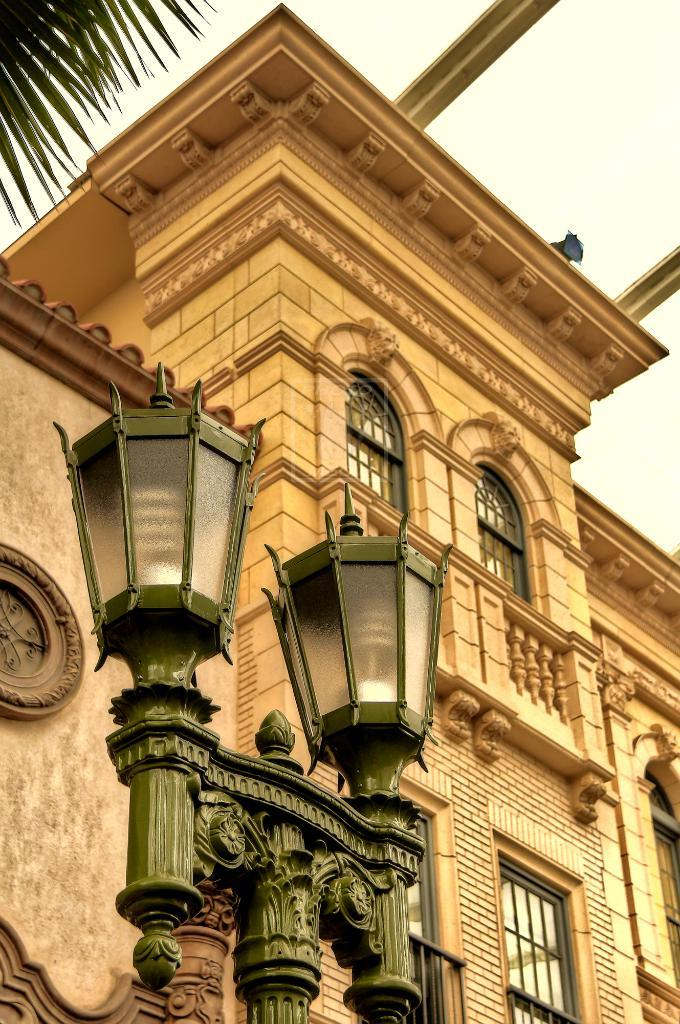What type of structure is present in the image? There is a building in the image. What feature of the building is mentioned in the facts? The building has windows. What can be observed about the windows in the image? The windows have lights. What other object is present in the image? There is a pole in the image. What type of natural element is present in the image? There is a tree in the image. What can be seen in the background of the image? The sky is visible in the background of the image. What type of nerve can be seen connecting the building and the tree in the image? There is no nerve present in the image; it features a building, windows with lights, a pole, a tree, and the sky in the background. 